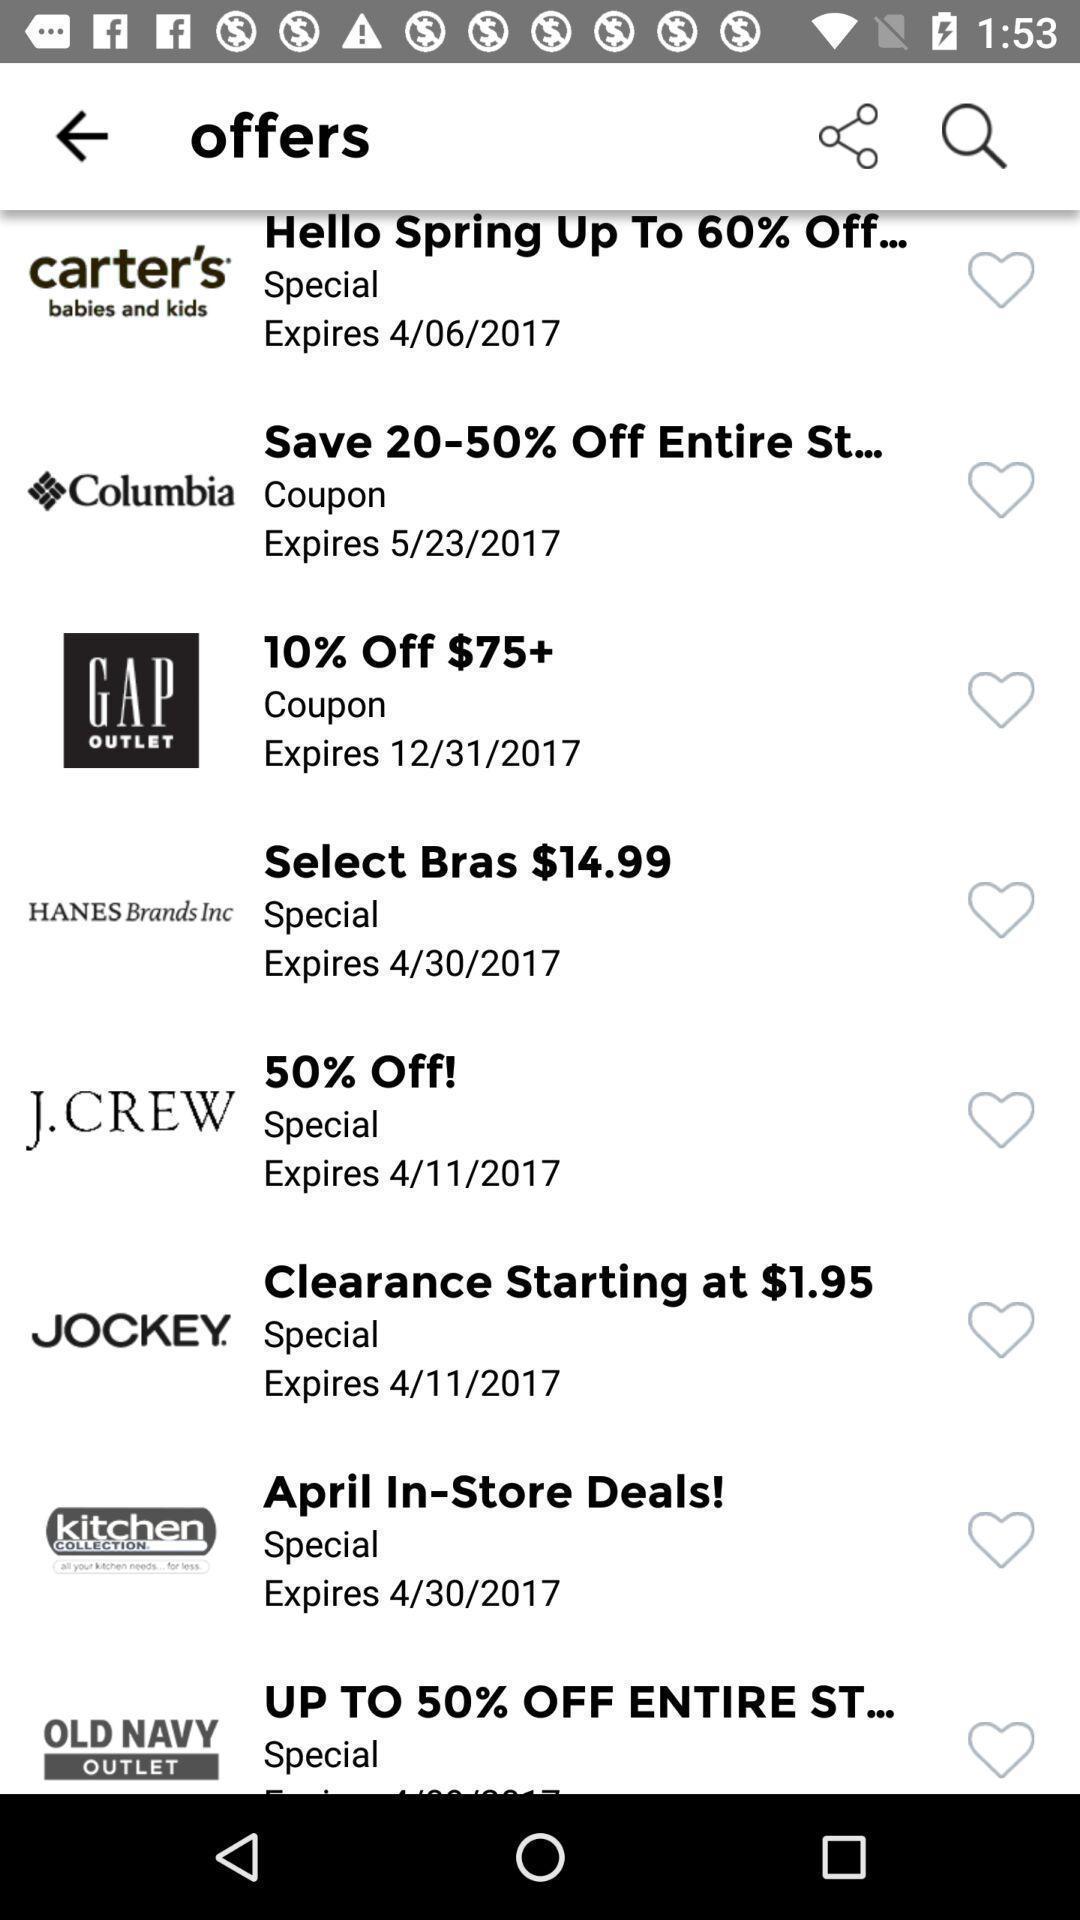Describe this image in words. Various offers list displayed. 